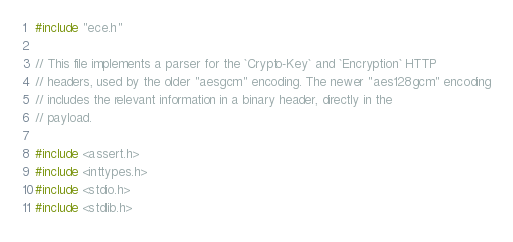Convert code to text. <code><loc_0><loc_0><loc_500><loc_500><_C_>#include "ece.h"

// This file implements a parser for the `Crypto-Key` and `Encryption` HTTP
// headers, used by the older "aesgcm" encoding. The newer "aes128gcm" encoding
// includes the relevant information in a binary header, directly in the
// payload.

#include <assert.h>
#include <inttypes.h>
#include <stdio.h>
#include <stdlib.h></code> 